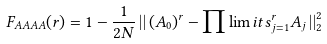Convert formula to latex. <formula><loc_0><loc_0><loc_500><loc_500>F _ { A A A A } ( r ) = 1 - \frac { 1 } { 2 N } \left | \right | ( A _ { 0 } ) ^ { r } - \prod \lim i t s _ { j = 1 } ^ { r } A _ { j } \left | \right | _ { 2 } ^ { 2 }</formula> 